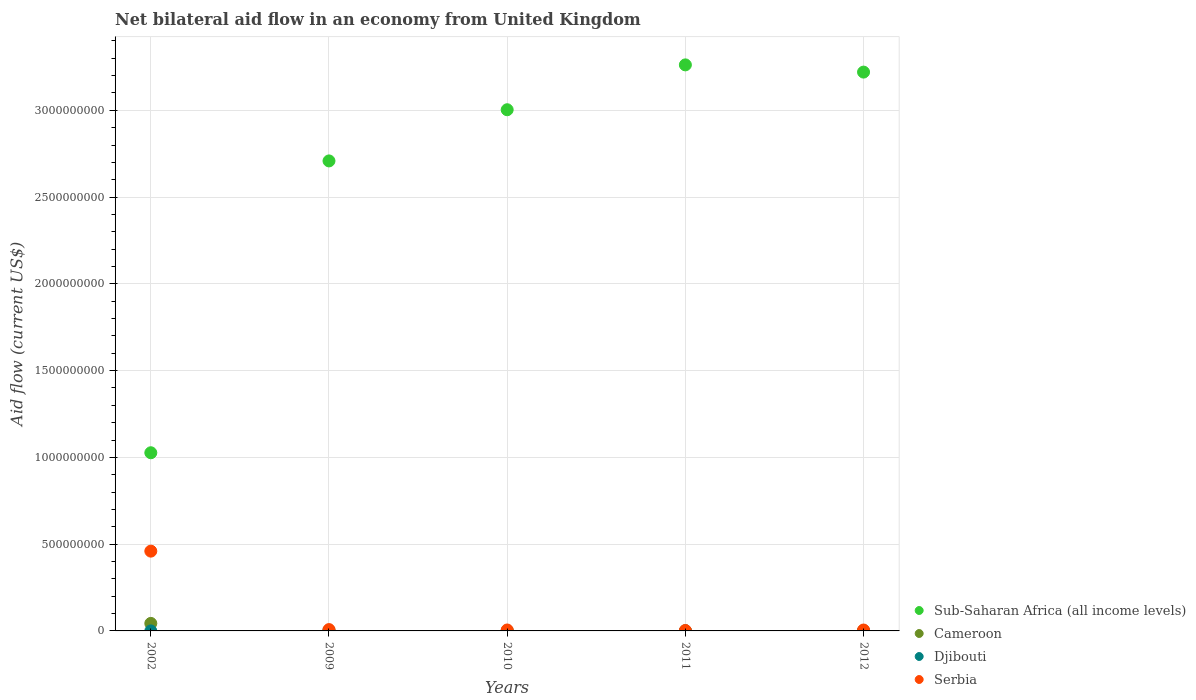How many different coloured dotlines are there?
Provide a short and direct response. 4. Is the number of dotlines equal to the number of legend labels?
Keep it short and to the point. Yes. What is the net bilateral aid flow in Serbia in 2012?
Give a very brief answer. 5.20e+06. Across all years, what is the maximum net bilateral aid flow in Serbia?
Your answer should be very brief. 4.60e+08. Across all years, what is the minimum net bilateral aid flow in Serbia?
Offer a terse response. 2.43e+06. In which year was the net bilateral aid flow in Serbia minimum?
Offer a very short reply. 2011. What is the total net bilateral aid flow in Serbia in the graph?
Offer a terse response. 4.80e+08. What is the difference between the net bilateral aid flow in Serbia in 2010 and that in 2012?
Ensure brevity in your answer.  2.00e+05. What is the difference between the net bilateral aid flow in Sub-Saharan Africa (all income levels) in 2009 and the net bilateral aid flow in Cameroon in 2012?
Provide a succinct answer. 2.71e+09. What is the average net bilateral aid flow in Cameroon per year?
Give a very brief answer. 9.88e+06. In the year 2012, what is the difference between the net bilateral aid flow in Sub-Saharan Africa (all income levels) and net bilateral aid flow in Djibouti?
Make the answer very short. 3.22e+09. What is the ratio of the net bilateral aid flow in Djibouti in 2010 to that in 2012?
Give a very brief answer. 0.09. Is the net bilateral aid flow in Djibouti in 2002 less than that in 2009?
Give a very brief answer. Yes. Is the difference between the net bilateral aid flow in Sub-Saharan Africa (all income levels) in 2002 and 2009 greater than the difference between the net bilateral aid flow in Djibouti in 2002 and 2009?
Make the answer very short. No. What is the difference between the highest and the second highest net bilateral aid flow in Djibouti?
Offer a terse response. 2.24e+06. What is the difference between the highest and the lowest net bilateral aid flow in Serbia?
Your answer should be very brief. 4.57e+08. Is it the case that in every year, the sum of the net bilateral aid flow in Cameroon and net bilateral aid flow in Serbia  is greater than the sum of net bilateral aid flow in Djibouti and net bilateral aid flow in Sub-Saharan Africa (all income levels)?
Ensure brevity in your answer.  Yes. Is the net bilateral aid flow in Cameroon strictly less than the net bilateral aid flow in Sub-Saharan Africa (all income levels) over the years?
Offer a very short reply. Yes. How many dotlines are there?
Make the answer very short. 4. How many years are there in the graph?
Ensure brevity in your answer.  5. Are the values on the major ticks of Y-axis written in scientific E-notation?
Your answer should be compact. No. What is the title of the graph?
Provide a succinct answer. Net bilateral aid flow in an economy from United Kingdom. What is the Aid flow (current US$) of Sub-Saharan Africa (all income levels) in 2002?
Ensure brevity in your answer.  1.03e+09. What is the Aid flow (current US$) in Cameroon in 2002?
Make the answer very short. 4.33e+07. What is the Aid flow (current US$) in Serbia in 2002?
Your response must be concise. 4.60e+08. What is the Aid flow (current US$) of Sub-Saharan Africa (all income levels) in 2009?
Make the answer very short. 2.71e+09. What is the Aid flow (current US$) of Cameroon in 2009?
Offer a very short reply. 2.26e+06. What is the Aid flow (current US$) of Djibouti in 2009?
Provide a short and direct response. 2.35e+06. What is the Aid flow (current US$) in Serbia in 2009?
Give a very brief answer. 7.72e+06. What is the Aid flow (current US$) in Sub-Saharan Africa (all income levels) in 2010?
Offer a very short reply. 3.00e+09. What is the Aid flow (current US$) in Cameroon in 2010?
Give a very brief answer. 1.03e+06. What is the Aid flow (current US$) of Djibouti in 2010?
Make the answer very short. 10000. What is the Aid flow (current US$) of Serbia in 2010?
Provide a succinct answer. 5.40e+06. What is the Aid flow (current US$) in Sub-Saharan Africa (all income levels) in 2011?
Your response must be concise. 3.26e+09. What is the Aid flow (current US$) in Cameroon in 2011?
Provide a succinct answer. 8.20e+05. What is the Aid flow (current US$) in Serbia in 2011?
Your response must be concise. 2.43e+06. What is the Aid flow (current US$) in Sub-Saharan Africa (all income levels) in 2012?
Keep it short and to the point. 3.22e+09. What is the Aid flow (current US$) of Cameroon in 2012?
Offer a very short reply. 1.96e+06. What is the Aid flow (current US$) of Djibouti in 2012?
Give a very brief answer. 1.10e+05. What is the Aid flow (current US$) of Serbia in 2012?
Keep it short and to the point. 5.20e+06. Across all years, what is the maximum Aid flow (current US$) in Sub-Saharan Africa (all income levels)?
Offer a terse response. 3.26e+09. Across all years, what is the maximum Aid flow (current US$) of Cameroon?
Offer a very short reply. 4.33e+07. Across all years, what is the maximum Aid flow (current US$) of Djibouti?
Ensure brevity in your answer.  2.35e+06. Across all years, what is the maximum Aid flow (current US$) in Serbia?
Keep it short and to the point. 4.60e+08. Across all years, what is the minimum Aid flow (current US$) of Sub-Saharan Africa (all income levels)?
Ensure brevity in your answer.  1.03e+09. Across all years, what is the minimum Aid flow (current US$) of Cameroon?
Keep it short and to the point. 8.20e+05. Across all years, what is the minimum Aid flow (current US$) of Djibouti?
Offer a terse response. 10000. Across all years, what is the minimum Aid flow (current US$) of Serbia?
Your response must be concise. 2.43e+06. What is the total Aid flow (current US$) of Sub-Saharan Africa (all income levels) in the graph?
Your answer should be very brief. 1.32e+1. What is the total Aid flow (current US$) of Cameroon in the graph?
Provide a short and direct response. 4.94e+07. What is the total Aid flow (current US$) of Djibouti in the graph?
Provide a short and direct response. 2.51e+06. What is the total Aid flow (current US$) of Serbia in the graph?
Make the answer very short. 4.80e+08. What is the difference between the Aid flow (current US$) in Sub-Saharan Africa (all income levels) in 2002 and that in 2009?
Provide a short and direct response. -1.68e+09. What is the difference between the Aid flow (current US$) of Cameroon in 2002 and that in 2009?
Your answer should be very brief. 4.11e+07. What is the difference between the Aid flow (current US$) in Djibouti in 2002 and that in 2009?
Keep it short and to the point. -2.33e+06. What is the difference between the Aid flow (current US$) in Serbia in 2002 and that in 2009?
Make the answer very short. 4.52e+08. What is the difference between the Aid flow (current US$) in Sub-Saharan Africa (all income levels) in 2002 and that in 2010?
Provide a succinct answer. -1.98e+09. What is the difference between the Aid flow (current US$) in Cameroon in 2002 and that in 2010?
Offer a terse response. 4.23e+07. What is the difference between the Aid flow (current US$) of Serbia in 2002 and that in 2010?
Your response must be concise. 4.54e+08. What is the difference between the Aid flow (current US$) in Sub-Saharan Africa (all income levels) in 2002 and that in 2011?
Your answer should be compact. -2.24e+09. What is the difference between the Aid flow (current US$) of Cameroon in 2002 and that in 2011?
Ensure brevity in your answer.  4.25e+07. What is the difference between the Aid flow (current US$) in Djibouti in 2002 and that in 2011?
Your answer should be very brief. 0. What is the difference between the Aid flow (current US$) of Serbia in 2002 and that in 2011?
Your answer should be very brief. 4.57e+08. What is the difference between the Aid flow (current US$) of Sub-Saharan Africa (all income levels) in 2002 and that in 2012?
Your response must be concise. -2.19e+09. What is the difference between the Aid flow (current US$) in Cameroon in 2002 and that in 2012?
Your response must be concise. 4.14e+07. What is the difference between the Aid flow (current US$) in Djibouti in 2002 and that in 2012?
Your answer should be very brief. -9.00e+04. What is the difference between the Aid flow (current US$) in Serbia in 2002 and that in 2012?
Provide a succinct answer. 4.55e+08. What is the difference between the Aid flow (current US$) of Sub-Saharan Africa (all income levels) in 2009 and that in 2010?
Keep it short and to the point. -2.95e+08. What is the difference between the Aid flow (current US$) of Cameroon in 2009 and that in 2010?
Provide a succinct answer. 1.23e+06. What is the difference between the Aid flow (current US$) of Djibouti in 2009 and that in 2010?
Make the answer very short. 2.34e+06. What is the difference between the Aid flow (current US$) in Serbia in 2009 and that in 2010?
Provide a succinct answer. 2.32e+06. What is the difference between the Aid flow (current US$) in Sub-Saharan Africa (all income levels) in 2009 and that in 2011?
Provide a succinct answer. -5.53e+08. What is the difference between the Aid flow (current US$) of Cameroon in 2009 and that in 2011?
Ensure brevity in your answer.  1.44e+06. What is the difference between the Aid flow (current US$) in Djibouti in 2009 and that in 2011?
Give a very brief answer. 2.33e+06. What is the difference between the Aid flow (current US$) in Serbia in 2009 and that in 2011?
Make the answer very short. 5.29e+06. What is the difference between the Aid flow (current US$) of Sub-Saharan Africa (all income levels) in 2009 and that in 2012?
Make the answer very short. -5.12e+08. What is the difference between the Aid flow (current US$) in Djibouti in 2009 and that in 2012?
Your answer should be compact. 2.24e+06. What is the difference between the Aid flow (current US$) of Serbia in 2009 and that in 2012?
Give a very brief answer. 2.52e+06. What is the difference between the Aid flow (current US$) of Sub-Saharan Africa (all income levels) in 2010 and that in 2011?
Give a very brief answer. -2.59e+08. What is the difference between the Aid flow (current US$) in Cameroon in 2010 and that in 2011?
Provide a short and direct response. 2.10e+05. What is the difference between the Aid flow (current US$) of Djibouti in 2010 and that in 2011?
Your answer should be very brief. -10000. What is the difference between the Aid flow (current US$) in Serbia in 2010 and that in 2011?
Give a very brief answer. 2.97e+06. What is the difference between the Aid flow (current US$) of Sub-Saharan Africa (all income levels) in 2010 and that in 2012?
Your answer should be very brief. -2.17e+08. What is the difference between the Aid flow (current US$) in Cameroon in 2010 and that in 2012?
Make the answer very short. -9.30e+05. What is the difference between the Aid flow (current US$) of Djibouti in 2010 and that in 2012?
Make the answer very short. -1.00e+05. What is the difference between the Aid flow (current US$) of Serbia in 2010 and that in 2012?
Make the answer very short. 2.00e+05. What is the difference between the Aid flow (current US$) in Sub-Saharan Africa (all income levels) in 2011 and that in 2012?
Ensure brevity in your answer.  4.16e+07. What is the difference between the Aid flow (current US$) of Cameroon in 2011 and that in 2012?
Make the answer very short. -1.14e+06. What is the difference between the Aid flow (current US$) in Djibouti in 2011 and that in 2012?
Keep it short and to the point. -9.00e+04. What is the difference between the Aid flow (current US$) of Serbia in 2011 and that in 2012?
Ensure brevity in your answer.  -2.77e+06. What is the difference between the Aid flow (current US$) in Sub-Saharan Africa (all income levels) in 2002 and the Aid flow (current US$) in Cameroon in 2009?
Provide a short and direct response. 1.02e+09. What is the difference between the Aid flow (current US$) of Sub-Saharan Africa (all income levels) in 2002 and the Aid flow (current US$) of Djibouti in 2009?
Keep it short and to the point. 1.02e+09. What is the difference between the Aid flow (current US$) in Sub-Saharan Africa (all income levels) in 2002 and the Aid flow (current US$) in Serbia in 2009?
Your response must be concise. 1.02e+09. What is the difference between the Aid flow (current US$) of Cameroon in 2002 and the Aid flow (current US$) of Djibouti in 2009?
Your answer should be compact. 4.10e+07. What is the difference between the Aid flow (current US$) of Cameroon in 2002 and the Aid flow (current US$) of Serbia in 2009?
Your response must be concise. 3.56e+07. What is the difference between the Aid flow (current US$) in Djibouti in 2002 and the Aid flow (current US$) in Serbia in 2009?
Keep it short and to the point. -7.70e+06. What is the difference between the Aid flow (current US$) in Sub-Saharan Africa (all income levels) in 2002 and the Aid flow (current US$) in Cameroon in 2010?
Provide a short and direct response. 1.03e+09. What is the difference between the Aid flow (current US$) of Sub-Saharan Africa (all income levels) in 2002 and the Aid flow (current US$) of Djibouti in 2010?
Your answer should be compact. 1.03e+09. What is the difference between the Aid flow (current US$) of Sub-Saharan Africa (all income levels) in 2002 and the Aid flow (current US$) of Serbia in 2010?
Provide a succinct answer. 1.02e+09. What is the difference between the Aid flow (current US$) in Cameroon in 2002 and the Aid flow (current US$) in Djibouti in 2010?
Keep it short and to the point. 4.33e+07. What is the difference between the Aid flow (current US$) of Cameroon in 2002 and the Aid flow (current US$) of Serbia in 2010?
Provide a short and direct response. 3.79e+07. What is the difference between the Aid flow (current US$) in Djibouti in 2002 and the Aid flow (current US$) in Serbia in 2010?
Offer a terse response. -5.38e+06. What is the difference between the Aid flow (current US$) in Sub-Saharan Africa (all income levels) in 2002 and the Aid flow (current US$) in Cameroon in 2011?
Give a very brief answer. 1.03e+09. What is the difference between the Aid flow (current US$) of Sub-Saharan Africa (all income levels) in 2002 and the Aid flow (current US$) of Djibouti in 2011?
Provide a short and direct response. 1.03e+09. What is the difference between the Aid flow (current US$) in Sub-Saharan Africa (all income levels) in 2002 and the Aid flow (current US$) in Serbia in 2011?
Give a very brief answer. 1.02e+09. What is the difference between the Aid flow (current US$) in Cameroon in 2002 and the Aid flow (current US$) in Djibouti in 2011?
Make the answer very short. 4.33e+07. What is the difference between the Aid flow (current US$) in Cameroon in 2002 and the Aid flow (current US$) in Serbia in 2011?
Provide a succinct answer. 4.09e+07. What is the difference between the Aid flow (current US$) in Djibouti in 2002 and the Aid flow (current US$) in Serbia in 2011?
Keep it short and to the point. -2.41e+06. What is the difference between the Aid flow (current US$) of Sub-Saharan Africa (all income levels) in 2002 and the Aid flow (current US$) of Cameroon in 2012?
Keep it short and to the point. 1.02e+09. What is the difference between the Aid flow (current US$) in Sub-Saharan Africa (all income levels) in 2002 and the Aid flow (current US$) in Djibouti in 2012?
Your answer should be very brief. 1.03e+09. What is the difference between the Aid flow (current US$) in Sub-Saharan Africa (all income levels) in 2002 and the Aid flow (current US$) in Serbia in 2012?
Give a very brief answer. 1.02e+09. What is the difference between the Aid flow (current US$) of Cameroon in 2002 and the Aid flow (current US$) of Djibouti in 2012?
Offer a terse response. 4.32e+07. What is the difference between the Aid flow (current US$) in Cameroon in 2002 and the Aid flow (current US$) in Serbia in 2012?
Your answer should be very brief. 3.81e+07. What is the difference between the Aid flow (current US$) in Djibouti in 2002 and the Aid flow (current US$) in Serbia in 2012?
Offer a very short reply. -5.18e+06. What is the difference between the Aid flow (current US$) in Sub-Saharan Africa (all income levels) in 2009 and the Aid flow (current US$) in Cameroon in 2010?
Provide a short and direct response. 2.71e+09. What is the difference between the Aid flow (current US$) in Sub-Saharan Africa (all income levels) in 2009 and the Aid flow (current US$) in Djibouti in 2010?
Offer a very short reply. 2.71e+09. What is the difference between the Aid flow (current US$) in Sub-Saharan Africa (all income levels) in 2009 and the Aid flow (current US$) in Serbia in 2010?
Give a very brief answer. 2.70e+09. What is the difference between the Aid flow (current US$) in Cameroon in 2009 and the Aid flow (current US$) in Djibouti in 2010?
Give a very brief answer. 2.25e+06. What is the difference between the Aid flow (current US$) in Cameroon in 2009 and the Aid flow (current US$) in Serbia in 2010?
Make the answer very short. -3.14e+06. What is the difference between the Aid flow (current US$) of Djibouti in 2009 and the Aid flow (current US$) of Serbia in 2010?
Make the answer very short. -3.05e+06. What is the difference between the Aid flow (current US$) in Sub-Saharan Africa (all income levels) in 2009 and the Aid flow (current US$) in Cameroon in 2011?
Give a very brief answer. 2.71e+09. What is the difference between the Aid flow (current US$) of Sub-Saharan Africa (all income levels) in 2009 and the Aid flow (current US$) of Djibouti in 2011?
Your answer should be very brief. 2.71e+09. What is the difference between the Aid flow (current US$) of Sub-Saharan Africa (all income levels) in 2009 and the Aid flow (current US$) of Serbia in 2011?
Provide a short and direct response. 2.71e+09. What is the difference between the Aid flow (current US$) in Cameroon in 2009 and the Aid flow (current US$) in Djibouti in 2011?
Provide a succinct answer. 2.24e+06. What is the difference between the Aid flow (current US$) of Sub-Saharan Africa (all income levels) in 2009 and the Aid flow (current US$) of Cameroon in 2012?
Your answer should be compact. 2.71e+09. What is the difference between the Aid flow (current US$) in Sub-Saharan Africa (all income levels) in 2009 and the Aid flow (current US$) in Djibouti in 2012?
Provide a short and direct response. 2.71e+09. What is the difference between the Aid flow (current US$) of Sub-Saharan Africa (all income levels) in 2009 and the Aid flow (current US$) of Serbia in 2012?
Provide a short and direct response. 2.70e+09. What is the difference between the Aid flow (current US$) of Cameroon in 2009 and the Aid flow (current US$) of Djibouti in 2012?
Offer a terse response. 2.15e+06. What is the difference between the Aid flow (current US$) of Cameroon in 2009 and the Aid flow (current US$) of Serbia in 2012?
Your answer should be very brief. -2.94e+06. What is the difference between the Aid flow (current US$) of Djibouti in 2009 and the Aid flow (current US$) of Serbia in 2012?
Give a very brief answer. -2.85e+06. What is the difference between the Aid flow (current US$) of Sub-Saharan Africa (all income levels) in 2010 and the Aid flow (current US$) of Cameroon in 2011?
Provide a succinct answer. 3.00e+09. What is the difference between the Aid flow (current US$) of Sub-Saharan Africa (all income levels) in 2010 and the Aid flow (current US$) of Djibouti in 2011?
Offer a very short reply. 3.00e+09. What is the difference between the Aid flow (current US$) of Sub-Saharan Africa (all income levels) in 2010 and the Aid flow (current US$) of Serbia in 2011?
Keep it short and to the point. 3.00e+09. What is the difference between the Aid flow (current US$) in Cameroon in 2010 and the Aid flow (current US$) in Djibouti in 2011?
Give a very brief answer. 1.01e+06. What is the difference between the Aid flow (current US$) in Cameroon in 2010 and the Aid flow (current US$) in Serbia in 2011?
Give a very brief answer. -1.40e+06. What is the difference between the Aid flow (current US$) of Djibouti in 2010 and the Aid flow (current US$) of Serbia in 2011?
Give a very brief answer. -2.42e+06. What is the difference between the Aid flow (current US$) of Sub-Saharan Africa (all income levels) in 2010 and the Aid flow (current US$) of Cameroon in 2012?
Your answer should be compact. 3.00e+09. What is the difference between the Aid flow (current US$) in Sub-Saharan Africa (all income levels) in 2010 and the Aid flow (current US$) in Djibouti in 2012?
Ensure brevity in your answer.  3.00e+09. What is the difference between the Aid flow (current US$) of Sub-Saharan Africa (all income levels) in 2010 and the Aid flow (current US$) of Serbia in 2012?
Ensure brevity in your answer.  3.00e+09. What is the difference between the Aid flow (current US$) of Cameroon in 2010 and the Aid flow (current US$) of Djibouti in 2012?
Keep it short and to the point. 9.20e+05. What is the difference between the Aid flow (current US$) of Cameroon in 2010 and the Aid flow (current US$) of Serbia in 2012?
Your answer should be very brief. -4.17e+06. What is the difference between the Aid flow (current US$) of Djibouti in 2010 and the Aid flow (current US$) of Serbia in 2012?
Offer a terse response. -5.19e+06. What is the difference between the Aid flow (current US$) of Sub-Saharan Africa (all income levels) in 2011 and the Aid flow (current US$) of Cameroon in 2012?
Provide a succinct answer. 3.26e+09. What is the difference between the Aid flow (current US$) in Sub-Saharan Africa (all income levels) in 2011 and the Aid flow (current US$) in Djibouti in 2012?
Provide a succinct answer. 3.26e+09. What is the difference between the Aid flow (current US$) of Sub-Saharan Africa (all income levels) in 2011 and the Aid flow (current US$) of Serbia in 2012?
Provide a short and direct response. 3.26e+09. What is the difference between the Aid flow (current US$) of Cameroon in 2011 and the Aid flow (current US$) of Djibouti in 2012?
Your answer should be very brief. 7.10e+05. What is the difference between the Aid flow (current US$) in Cameroon in 2011 and the Aid flow (current US$) in Serbia in 2012?
Give a very brief answer. -4.38e+06. What is the difference between the Aid flow (current US$) in Djibouti in 2011 and the Aid flow (current US$) in Serbia in 2012?
Your answer should be very brief. -5.18e+06. What is the average Aid flow (current US$) in Sub-Saharan Africa (all income levels) per year?
Ensure brevity in your answer.  2.64e+09. What is the average Aid flow (current US$) of Cameroon per year?
Provide a short and direct response. 9.88e+06. What is the average Aid flow (current US$) in Djibouti per year?
Your answer should be compact. 5.02e+05. What is the average Aid flow (current US$) in Serbia per year?
Offer a terse response. 9.61e+07. In the year 2002, what is the difference between the Aid flow (current US$) in Sub-Saharan Africa (all income levels) and Aid flow (current US$) in Cameroon?
Your answer should be compact. 9.83e+08. In the year 2002, what is the difference between the Aid flow (current US$) in Sub-Saharan Africa (all income levels) and Aid flow (current US$) in Djibouti?
Provide a succinct answer. 1.03e+09. In the year 2002, what is the difference between the Aid flow (current US$) of Sub-Saharan Africa (all income levels) and Aid flow (current US$) of Serbia?
Keep it short and to the point. 5.67e+08. In the year 2002, what is the difference between the Aid flow (current US$) of Cameroon and Aid flow (current US$) of Djibouti?
Your answer should be very brief. 4.33e+07. In the year 2002, what is the difference between the Aid flow (current US$) of Cameroon and Aid flow (current US$) of Serbia?
Keep it short and to the point. -4.16e+08. In the year 2002, what is the difference between the Aid flow (current US$) of Djibouti and Aid flow (current US$) of Serbia?
Your answer should be compact. -4.60e+08. In the year 2009, what is the difference between the Aid flow (current US$) of Sub-Saharan Africa (all income levels) and Aid flow (current US$) of Cameroon?
Provide a succinct answer. 2.71e+09. In the year 2009, what is the difference between the Aid flow (current US$) in Sub-Saharan Africa (all income levels) and Aid flow (current US$) in Djibouti?
Ensure brevity in your answer.  2.71e+09. In the year 2009, what is the difference between the Aid flow (current US$) of Sub-Saharan Africa (all income levels) and Aid flow (current US$) of Serbia?
Your response must be concise. 2.70e+09. In the year 2009, what is the difference between the Aid flow (current US$) of Cameroon and Aid flow (current US$) of Djibouti?
Keep it short and to the point. -9.00e+04. In the year 2009, what is the difference between the Aid flow (current US$) in Cameroon and Aid flow (current US$) in Serbia?
Make the answer very short. -5.46e+06. In the year 2009, what is the difference between the Aid flow (current US$) in Djibouti and Aid flow (current US$) in Serbia?
Ensure brevity in your answer.  -5.37e+06. In the year 2010, what is the difference between the Aid flow (current US$) of Sub-Saharan Africa (all income levels) and Aid flow (current US$) of Cameroon?
Offer a terse response. 3.00e+09. In the year 2010, what is the difference between the Aid flow (current US$) in Sub-Saharan Africa (all income levels) and Aid flow (current US$) in Djibouti?
Make the answer very short. 3.00e+09. In the year 2010, what is the difference between the Aid flow (current US$) of Sub-Saharan Africa (all income levels) and Aid flow (current US$) of Serbia?
Your response must be concise. 3.00e+09. In the year 2010, what is the difference between the Aid flow (current US$) of Cameroon and Aid flow (current US$) of Djibouti?
Your answer should be compact. 1.02e+06. In the year 2010, what is the difference between the Aid flow (current US$) of Cameroon and Aid flow (current US$) of Serbia?
Offer a very short reply. -4.37e+06. In the year 2010, what is the difference between the Aid flow (current US$) in Djibouti and Aid flow (current US$) in Serbia?
Give a very brief answer. -5.39e+06. In the year 2011, what is the difference between the Aid flow (current US$) of Sub-Saharan Africa (all income levels) and Aid flow (current US$) of Cameroon?
Your answer should be very brief. 3.26e+09. In the year 2011, what is the difference between the Aid flow (current US$) of Sub-Saharan Africa (all income levels) and Aid flow (current US$) of Djibouti?
Ensure brevity in your answer.  3.26e+09. In the year 2011, what is the difference between the Aid flow (current US$) in Sub-Saharan Africa (all income levels) and Aid flow (current US$) in Serbia?
Provide a succinct answer. 3.26e+09. In the year 2011, what is the difference between the Aid flow (current US$) in Cameroon and Aid flow (current US$) in Djibouti?
Make the answer very short. 8.00e+05. In the year 2011, what is the difference between the Aid flow (current US$) of Cameroon and Aid flow (current US$) of Serbia?
Your answer should be very brief. -1.61e+06. In the year 2011, what is the difference between the Aid flow (current US$) in Djibouti and Aid flow (current US$) in Serbia?
Give a very brief answer. -2.41e+06. In the year 2012, what is the difference between the Aid flow (current US$) of Sub-Saharan Africa (all income levels) and Aid flow (current US$) of Cameroon?
Ensure brevity in your answer.  3.22e+09. In the year 2012, what is the difference between the Aid flow (current US$) of Sub-Saharan Africa (all income levels) and Aid flow (current US$) of Djibouti?
Offer a terse response. 3.22e+09. In the year 2012, what is the difference between the Aid flow (current US$) in Sub-Saharan Africa (all income levels) and Aid flow (current US$) in Serbia?
Make the answer very short. 3.21e+09. In the year 2012, what is the difference between the Aid flow (current US$) of Cameroon and Aid flow (current US$) of Djibouti?
Your response must be concise. 1.85e+06. In the year 2012, what is the difference between the Aid flow (current US$) of Cameroon and Aid flow (current US$) of Serbia?
Provide a short and direct response. -3.24e+06. In the year 2012, what is the difference between the Aid flow (current US$) in Djibouti and Aid flow (current US$) in Serbia?
Keep it short and to the point. -5.09e+06. What is the ratio of the Aid flow (current US$) of Sub-Saharan Africa (all income levels) in 2002 to that in 2009?
Ensure brevity in your answer.  0.38. What is the ratio of the Aid flow (current US$) of Cameroon in 2002 to that in 2009?
Keep it short and to the point. 19.17. What is the ratio of the Aid flow (current US$) of Djibouti in 2002 to that in 2009?
Your answer should be very brief. 0.01. What is the ratio of the Aid flow (current US$) in Serbia in 2002 to that in 2009?
Offer a very short reply. 59.55. What is the ratio of the Aid flow (current US$) in Sub-Saharan Africa (all income levels) in 2002 to that in 2010?
Keep it short and to the point. 0.34. What is the ratio of the Aid flow (current US$) of Cameroon in 2002 to that in 2010?
Ensure brevity in your answer.  42.07. What is the ratio of the Aid flow (current US$) in Djibouti in 2002 to that in 2010?
Your answer should be compact. 2. What is the ratio of the Aid flow (current US$) in Serbia in 2002 to that in 2010?
Your answer should be compact. 85.14. What is the ratio of the Aid flow (current US$) in Sub-Saharan Africa (all income levels) in 2002 to that in 2011?
Your answer should be compact. 0.31. What is the ratio of the Aid flow (current US$) of Cameroon in 2002 to that in 2011?
Keep it short and to the point. 52.84. What is the ratio of the Aid flow (current US$) of Djibouti in 2002 to that in 2011?
Make the answer very short. 1. What is the ratio of the Aid flow (current US$) in Serbia in 2002 to that in 2011?
Offer a very short reply. 189.19. What is the ratio of the Aid flow (current US$) in Sub-Saharan Africa (all income levels) in 2002 to that in 2012?
Offer a very short reply. 0.32. What is the ratio of the Aid flow (current US$) in Cameroon in 2002 to that in 2012?
Your answer should be very brief. 22.11. What is the ratio of the Aid flow (current US$) in Djibouti in 2002 to that in 2012?
Offer a very short reply. 0.18. What is the ratio of the Aid flow (current US$) of Serbia in 2002 to that in 2012?
Your answer should be compact. 88.41. What is the ratio of the Aid flow (current US$) of Sub-Saharan Africa (all income levels) in 2009 to that in 2010?
Give a very brief answer. 0.9. What is the ratio of the Aid flow (current US$) of Cameroon in 2009 to that in 2010?
Your answer should be compact. 2.19. What is the ratio of the Aid flow (current US$) of Djibouti in 2009 to that in 2010?
Provide a succinct answer. 235. What is the ratio of the Aid flow (current US$) in Serbia in 2009 to that in 2010?
Your answer should be very brief. 1.43. What is the ratio of the Aid flow (current US$) of Sub-Saharan Africa (all income levels) in 2009 to that in 2011?
Your response must be concise. 0.83. What is the ratio of the Aid flow (current US$) of Cameroon in 2009 to that in 2011?
Provide a succinct answer. 2.76. What is the ratio of the Aid flow (current US$) in Djibouti in 2009 to that in 2011?
Your response must be concise. 117.5. What is the ratio of the Aid flow (current US$) in Serbia in 2009 to that in 2011?
Your answer should be very brief. 3.18. What is the ratio of the Aid flow (current US$) in Sub-Saharan Africa (all income levels) in 2009 to that in 2012?
Give a very brief answer. 0.84. What is the ratio of the Aid flow (current US$) in Cameroon in 2009 to that in 2012?
Your answer should be compact. 1.15. What is the ratio of the Aid flow (current US$) of Djibouti in 2009 to that in 2012?
Keep it short and to the point. 21.36. What is the ratio of the Aid flow (current US$) in Serbia in 2009 to that in 2012?
Give a very brief answer. 1.48. What is the ratio of the Aid flow (current US$) in Sub-Saharan Africa (all income levels) in 2010 to that in 2011?
Provide a short and direct response. 0.92. What is the ratio of the Aid flow (current US$) of Cameroon in 2010 to that in 2011?
Provide a short and direct response. 1.26. What is the ratio of the Aid flow (current US$) of Serbia in 2010 to that in 2011?
Offer a very short reply. 2.22. What is the ratio of the Aid flow (current US$) in Sub-Saharan Africa (all income levels) in 2010 to that in 2012?
Give a very brief answer. 0.93. What is the ratio of the Aid flow (current US$) in Cameroon in 2010 to that in 2012?
Give a very brief answer. 0.53. What is the ratio of the Aid flow (current US$) in Djibouti in 2010 to that in 2012?
Ensure brevity in your answer.  0.09. What is the ratio of the Aid flow (current US$) of Sub-Saharan Africa (all income levels) in 2011 to that in 2012?
Your answer should be compact. 1.01. What is the ratio of the Aid flow (current US$) in Cameroon in 2011 to that in 2012?
Provide a succinct answer. 0.42. What is the ratio of the Aid flow (current US$) in Djibouti in 2011 to that in 2012?
Your answer should be compact. 0.18. What is the ratio of the Aid flow (current US$) of Serbia in 2011 to that in 2012?
Your answer should be compact. 0.47. What is the difference between the highest and the second highest Aid flow (current US$) of Sub-Saharan Africa (all income levels)?
Your response must be concise. 4.16e+07. What is the difference between the highest and the second highest Aid flow (current US$) in Cameroon?
Your response must be concise. 4.11e+07. What is the difference between the highest and the second highest Aid flow (current US$) in Djibouti?
Your answer should be compact. 2.24e+06. What is the difference between the highest and the second highest Aid flow (current US$) in Serbia?
Ensure brevity in your answer.  4.52e+08. What is the difference between the highest and the lowest Aid flow (current US$) in Sub-Saharan Africa (all income levels)?
Ensure brevity in your answer.  2.24e+09. What is the difference between the highest and the lowest Aid flow (current US$) of Cameroon?
Your answer should be very brief. 4.25e+07. What is the difference between the highest and the lowest Aid flow (current US$) in Djibouti?
Provide a short and direct response. 2.34e+06. What is the difference between the highest and the lowest Aid flow (current US$) of Serbia?
Provide a succinct answer. 4.57e+08. 